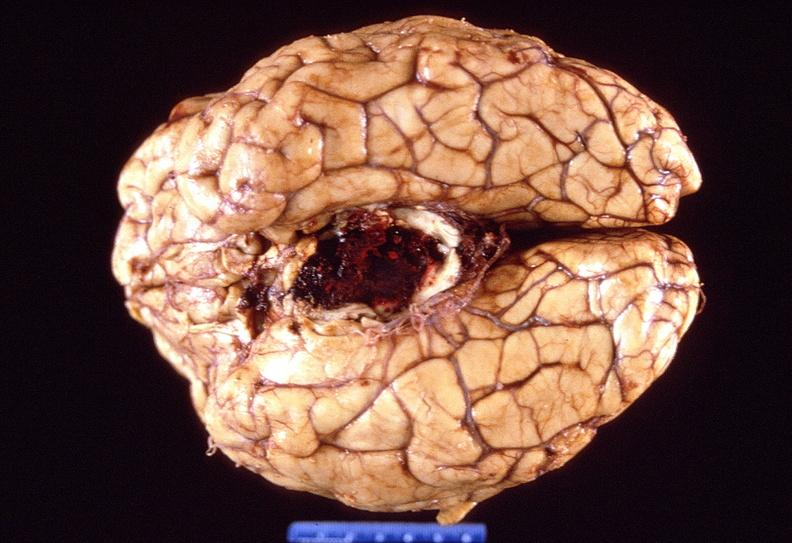does metastatic adenocarcinoma show brain, intracerebral hemorrhage?
Answer the question using a single word or phrase. No 